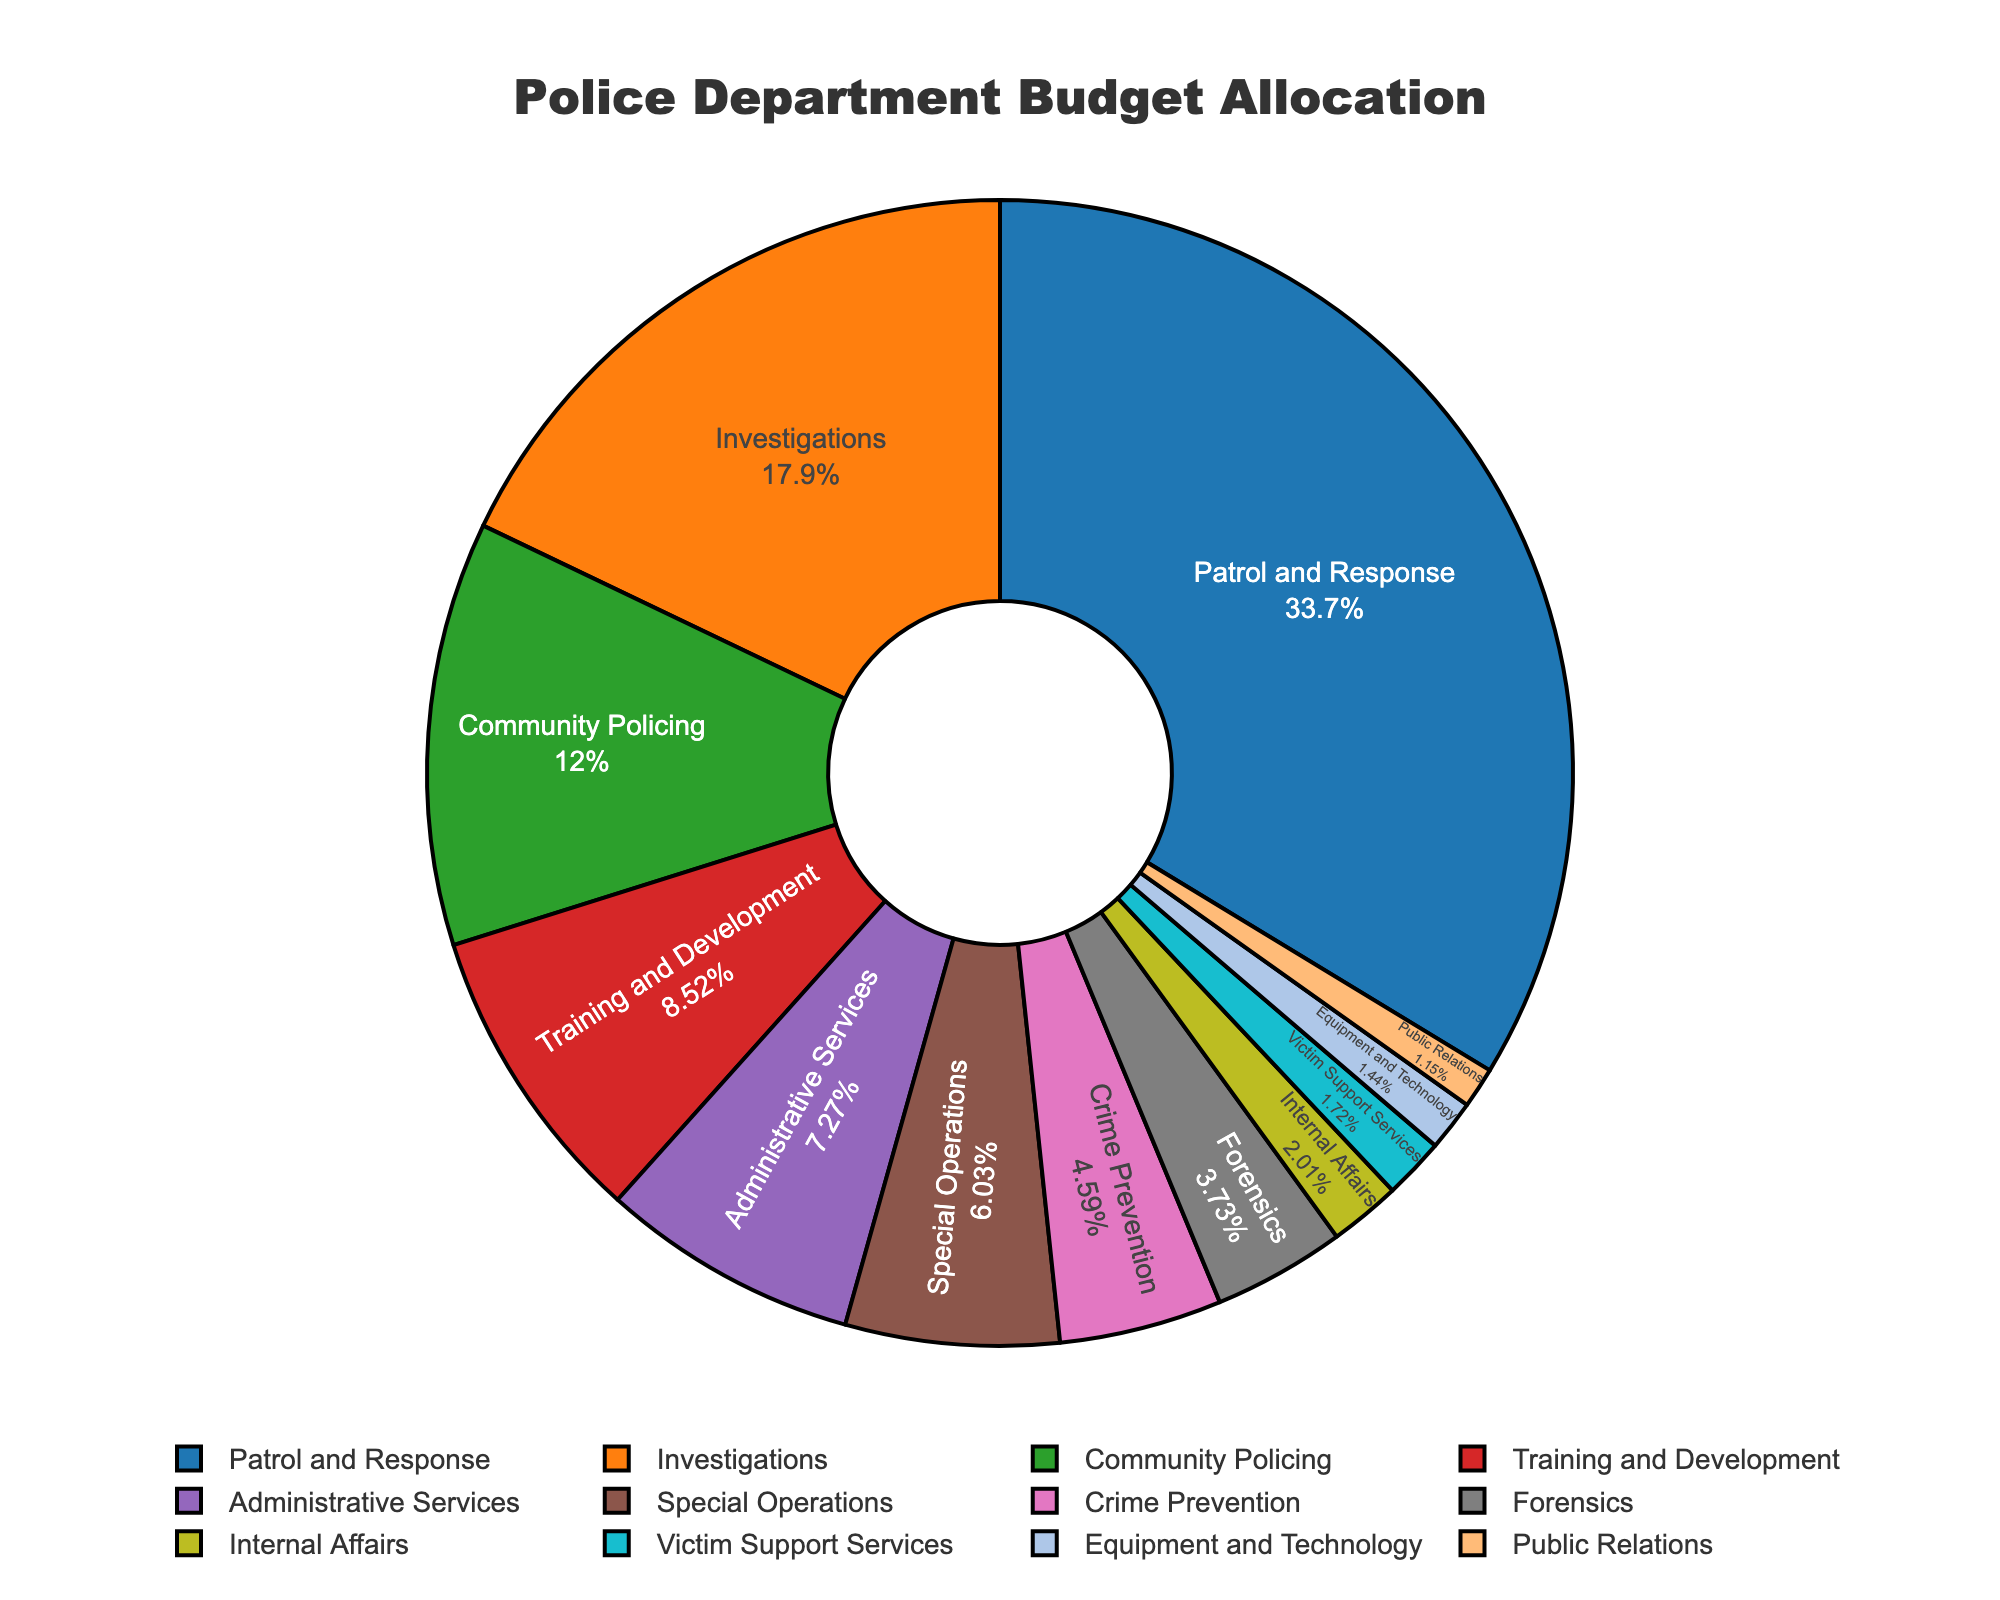What is the largest budget allocation in the police department's budget? The section labeled "Patrol and Response" occupies the largest space on the pie chart, indicating it has the largest budget allocation.
Answer: Patrol and Response What is the combined budget allocation for Community Policing and Training and Development? Community Policing has 12.5% and Training and Development has 8.9%. Adding these together gives 21.4%.
Answer: 21.4% Which unit has a greater budget allocation: Forensics or Special Operations? The pie chart shows that Forensics has 3.9% while Special Operations has 6.3%. Special Operations has a greater budget allocation.
Answer: Special Operations What is the difference in budget allocation between Investigations and Administrative Services? Investigations is at 18.7% whereas Administrative Services is at 7.6%. Subtracting these gives 18.7 - 7.6 = 11.1%.
Answer: 11.1% Which unit has the smallest budget allocation? The smallest section on the pie chart is labeled "Public Relations," showing it has the smallest budget allocation.
Answer: Public Relations Compare and contrast the budget allocation between Equipment and Technology and Victim Support Services. Equipment and Technology has a budget allocation of 1.5%, whereas Victim Support Services has 1.8%. Thus, Victim Support Services has a slightly higher allocation.
Answer: Victim Support Services What is the total budget allocation for units with less than 5% allocation each? Units with less than 5% allocation are Crime Prevention (4.8%), Forensics (3.9%), Internal Affairs (2.1%), Victim Support Services (1.8%), Equipment and Technology (1.5%), and Public Relations (1.2%). Summing these gives 4.8 + 3.9 + 2.1 + 1.8 + 1.5 + 1.2 = 15.3%.
Answer: 15.3% What is the proportion of the budget allocated to Patrol and Response compared to the total for Internal Affairs and Public Relations combined? Patrol and Response has 35.2%. Internal Affairs has 2.1% and Public Relations has 1.2%, together making 2.1 + 1.2 = 3.3%. The proportion is 35.2 / 3.3.
Answer: 10.67 Which unit has a similar budget allocation to Training and Development when combined with Internal Affairs? Training and Development has 8.9% and Internal Affairs has 2.1%. Combined, this gives 8.9 + 2.1 = 11%. The unit with a budget allocation closest to 11% is Community Policing at 12.5%.
Answer: Community Policing What is the sum of budget allocations for units related to crime response and prevention? (Patrol and Response, Investigations, Crime Prevention) Patrol and Response has 35.2%, Investigations has 18.7%, and Crime Prevention has 4.8%. Adding these together gives 35.2 + 18.7 + 4.8 = 58.7%.
Answer: 58.7% 